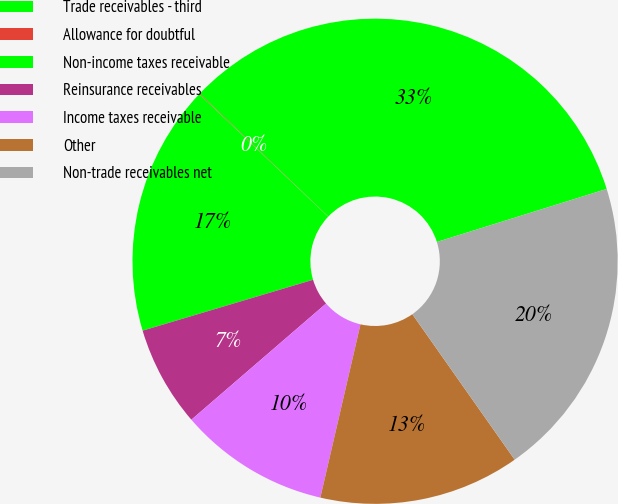Convert chart. <chart><loc_0><loc_0><loc_500><loc_500><pie_chart><fcel>Trade receivables - third<fcel>Allowance for doubtful<fcel>Non-income taxes receivable<fcel>Reinsurance receivables<fcel>Income taxes receivable<fcel>Other<fcel>Non-trade receivables net<nl><fcel>33.04%<fcel>0.04%<fcel>16.72%<fcel>6.71%<fcel>10.05%<fcel>13.38%<fcel>20.06%<nl></chart> 